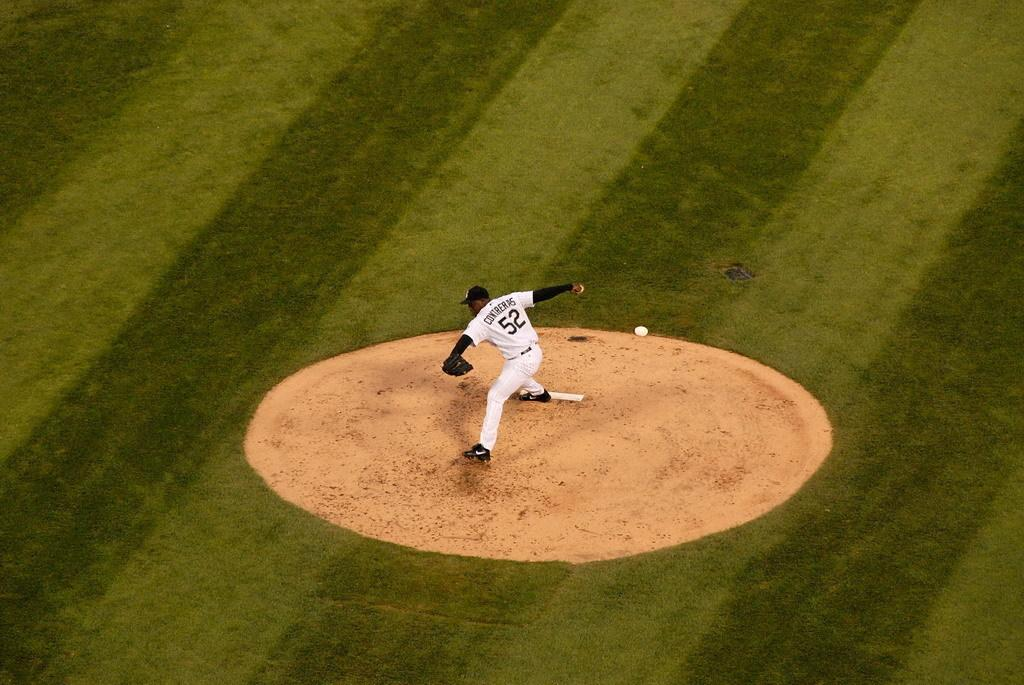Provide a one-sentence caption for the provided image. Contreras wears number 52 and is about to pitch the baseball. 